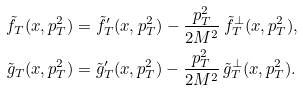<formula> <loc_0><loc_0><loc_500><loc_500>\tilde { f } _ { T } ( x , p _ { T } ^ { 2 } ) & = \tilde { f } _ { T } ^ { \prime } ( x , p _ { T } ^ { 2 } ) - \frac { p _ { T } ^ { 2 } } { 2 M ^ { 2 } } \, \tilde { f } _ { T } ^ { \perp } ( x , p _ { T } ^ { 2 } ) , \\ \tilde { g } _ { T } ( x , p _ { T } ^ { 2 } ) & = \tilde { g } _ { T } ^ { \prime } ( x , p _ { T } ^ { 2 } ) - \frac { p _ { T } ^ { 2 } } { 2 M ^ { 2 } } \, \tilde { g } _ { T } ^ { \perp } ( x , p _ { T } ^ { 2 } ) .</formula> 